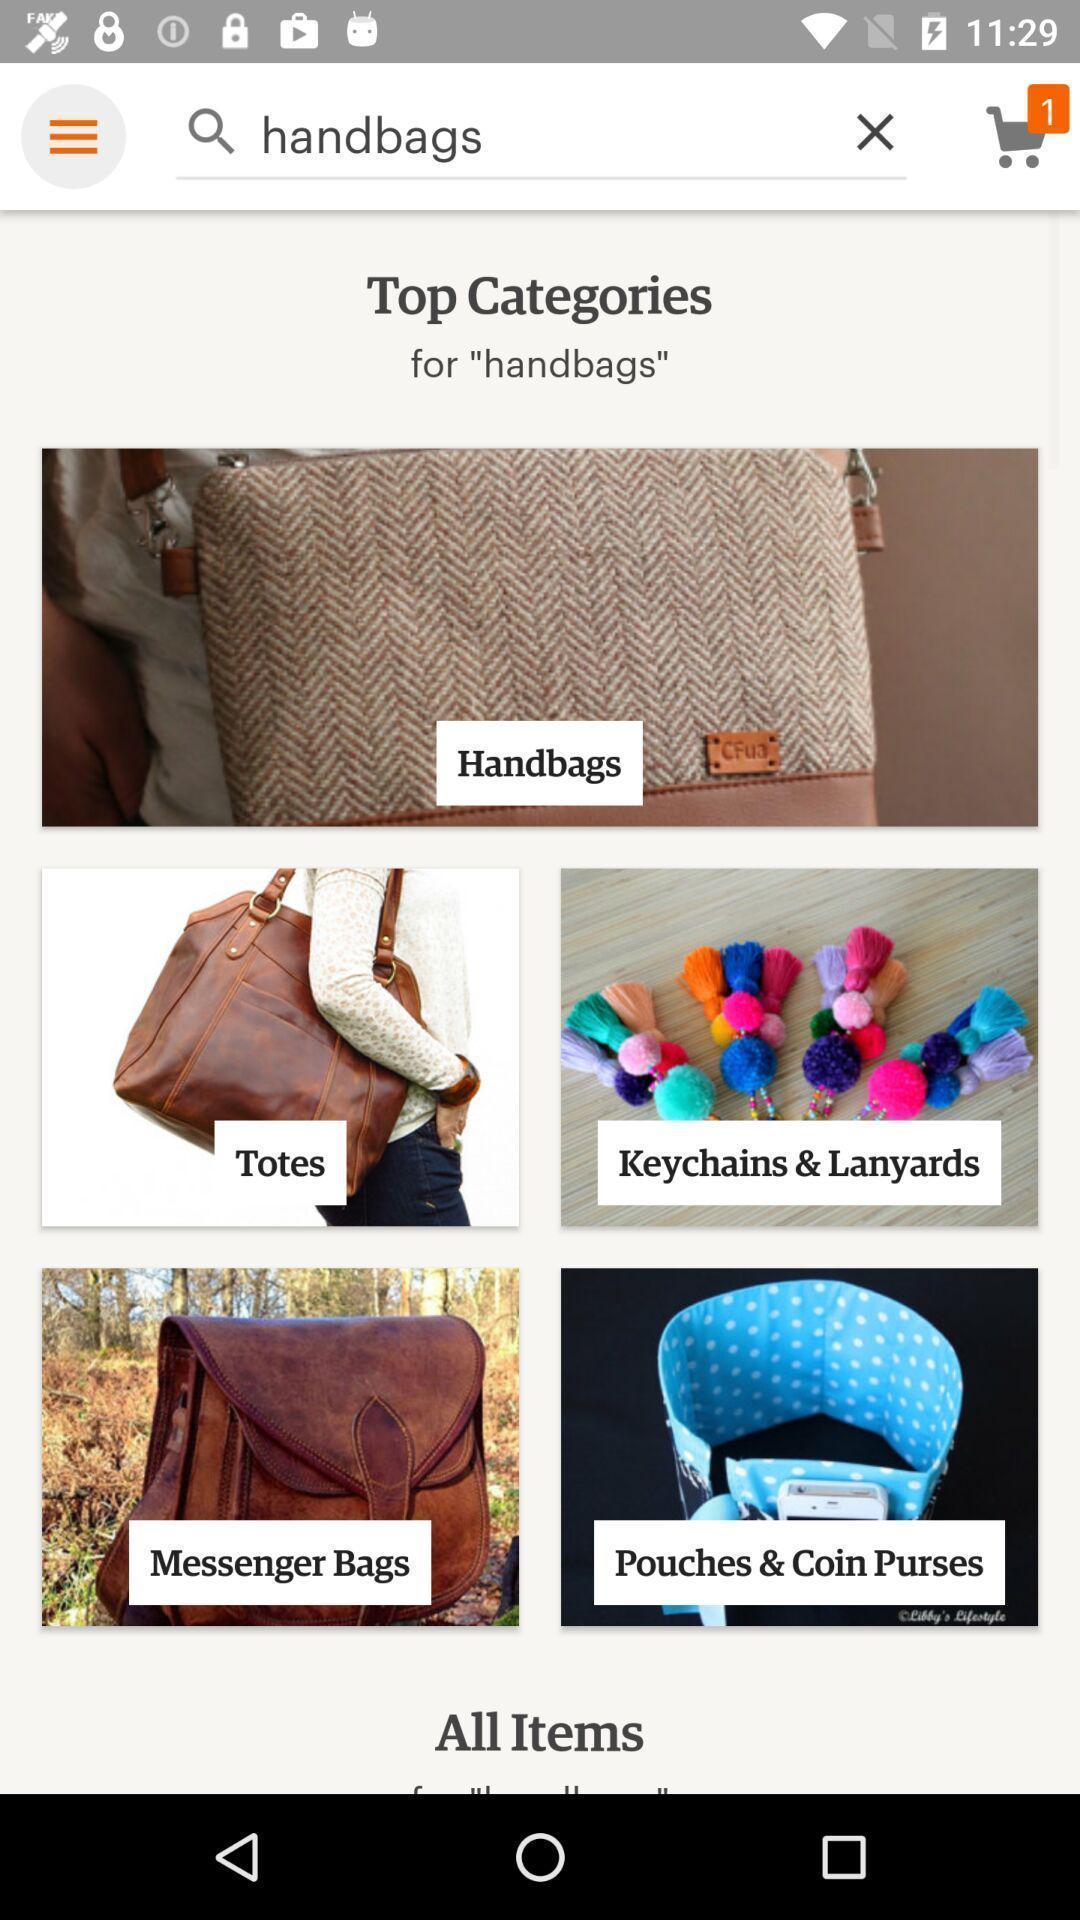What is the overall content of this screenshot? Shopping items in a shopping app. 